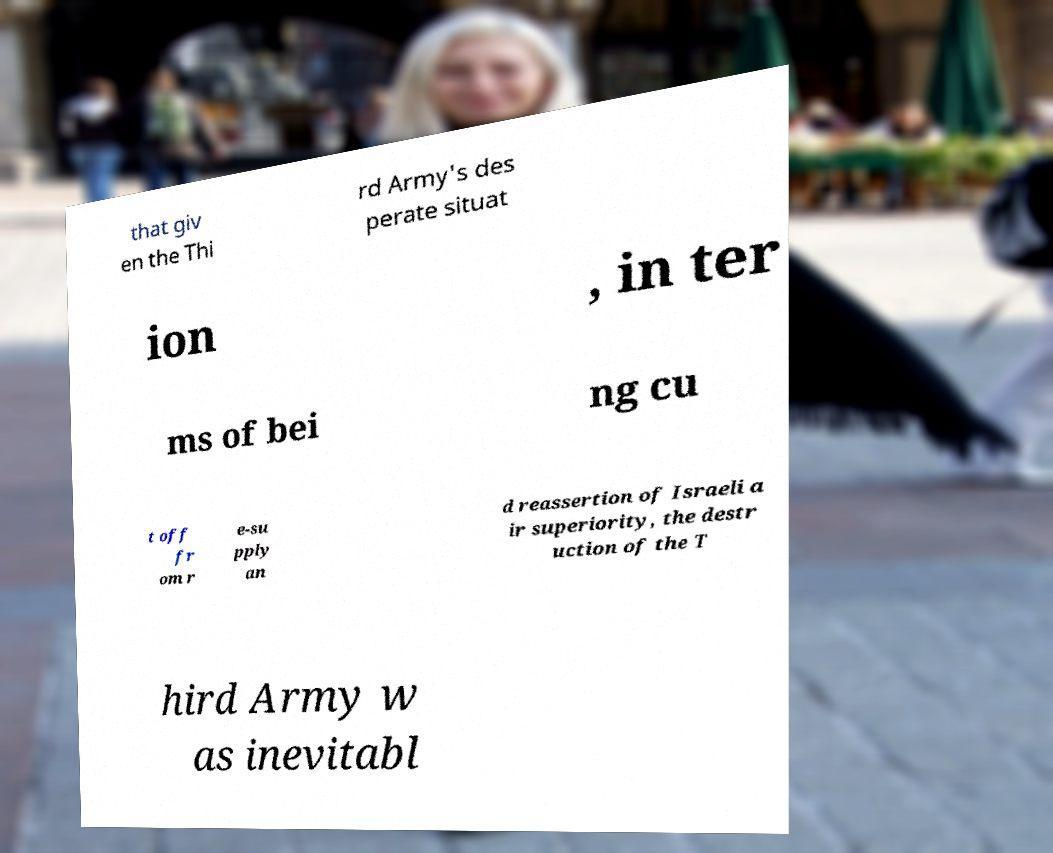Could you extract and type out the text from this image? that giv en the Thi rd Army's des perate situat ion , in ter ms of bei ng cu t off fr om r e-su pply an d reassertion of Israeli a ir superiority, the destr uction of the T hird Army w as inevitabl 